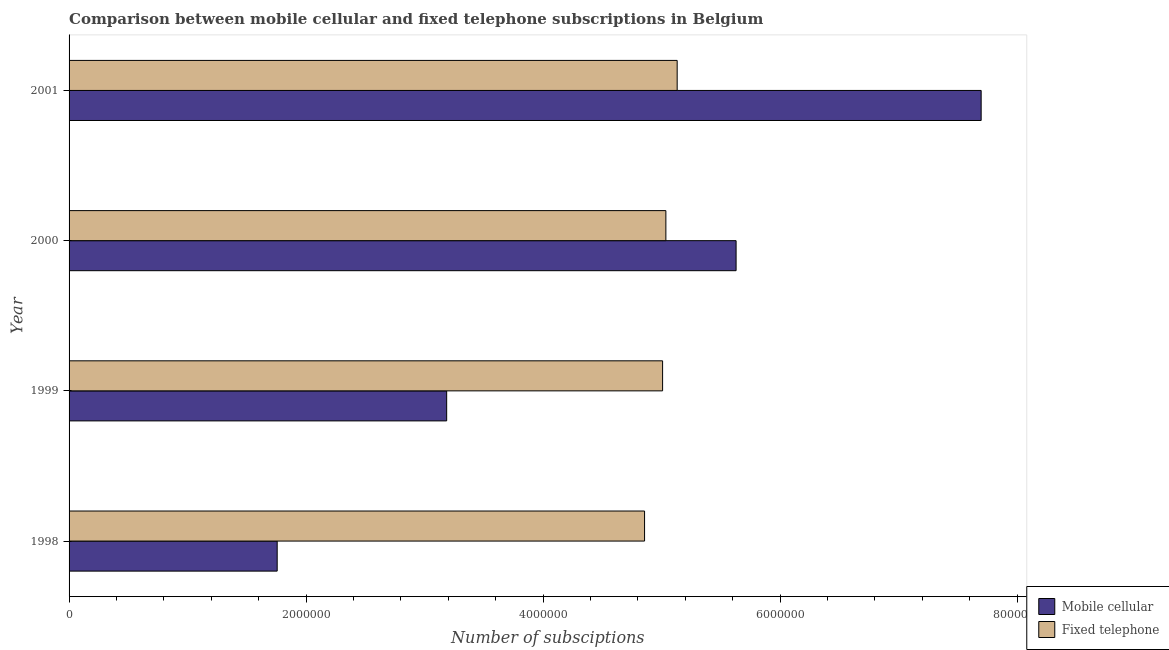How many different coloured bars are there?
Provide a succinct answer. 2. How many groups of bars are there?
Offer a very short reply. 4. Are the number of bars per tick equal to the number of legend labels?
Offer a terse response. Yes. Are the number of bars on each tick of the Y-axis equal?
Ensure brevity in your answer.  Yes. How many bars are there on the 3rd tick from the top?
Offer a terse response. 2. What is the label of the 2nd group of bars from the top?
Provide a succinct answer. 2000. In how many cases, is the number of bars for a given year not equal to the number of legend labels?
Your response must be concise. 0. What is the number of fixed telephone subscriptions in 2000?
Offer a very short reply. 5.04e+06. Across all years, what is the maximum number of mobile cellular subscriptions?
Your response must be concise. 7.70e+06. Across all years, what is the minimum number of mobile cellular subscriptions?
Your answer should be compact. 1.76e+06. In which year was the number of fixed telephone subscriptions maximum?
Provide a short and direct response. 2001. In which year was the number of mobile cellular subscriptions minimum?
Ensure brevity in your answer.  1998. What is the total number of mobile cellular subscriptions in the graph?
Your answer should be compact. 1.83e+07. What is the difference between the number of mobile cellular subscriptions in 1998 and that in 1999?
Give a very brief answer. -1.43e+06. What is the difference between the number of fixed telephone subscriptions in 1999 and the number of mobile cellular subscriptions in 2001?
Offer a very short reply. -2.69e+06. What is the average number of fixed telephone subscriptions per year?
Provide a short and direct response. 5.01e+06. In the year 2001, what is the difference between the number of mobile cellular subscriptions and number of fixed telephone subscriptions?
Give a very brief answer. 2.57e+06. In how many years, is the number of mobile cellular subscriptions greater than 2800000 ?
Ensure brevity in your answer.  3. What is the ratio of the number of fixed telephone subscriptions in 1999 to that in 2000?
Your answer should be very brief. 0.99. What is the difference between the highest and the second highest number of fixed telephone subscriptions?
Provide a succinct answer. 9.53e+04. What is the difference between the highest and the lowest number of mobile cellular subscriptions?
Offer a very short reply. 5.94e+06. What does the 1st bar from the top in 2000 represents?
Offer a terse response. Fixed telephone. What does the 2nd bar from the bottom in 1998 represents?
Give a very brief answer. Fixed telephone. Are all the bars in the graph horizontal?
Make the answer very short. Yes. How many years are there in the graph?
Offer a very short reply. 4. Does the graph contain grids?
Make the answer very short. No. Where does the legend appear in the graph?
Offer a terse response. Bottom right. What is the title of the graph?
Keep it short and to the point. Comparison between mobile cellular and fixed telephone subscriptions in Belgium. What is the label or title of the X-axis?
Provide a succinct answer. Number of subsciptions. What is the Number of subsciptions in Mobile cellular in 1998?
Your answer should be compact. 1.76e+06. What is the Number of subsciptions in Fixed telephone in 1998?
Your answer should be compact. 4.86e+06. What is the Number of subsciptions in Mobile cellular in 1999?
Make the answer very short. 3.19e+06. What is the Number of subsciptions in Fixed telephone in 1999?
Offer a very short reply. 5.01e+06. What is the Number of subsciptions in Mobile cellular in 2000?
Make the answer very short. 5.63e+06. What is the Number of subsciptions of Fixed telephone in 2000?
Give a very brief answer. 5.04e+06. What is the Number of subsciptions of Mobile cellular in 2001?
Provide a short and direct response. 7.70e+06. What is the Number of subsciptions in Fixed telephone in 2001?
Your answer should be very brief. 5.13e+06. Across all years, what is the maximum Number of subsciptions in Mobile cellular?
Ensure brevity in your answer.  7.70e+06. Across all years, what is the maximum Number of subsciptions of Fixed telephone?
Your answer should be compact. 5.13e+06. Across all years, what is the minimum Number of subsciptions in Mobile cellular?
Ensure brevity in your answer.  1.76e+06. Across all years, what is the minimum Number of subsciptions in Fixed telephone?
Ensure brevity in your answer.  4.86e+06. What is the total Number of subsciptions of Mobile cellular in the graph?
Ensure brevity in your answer.  1.83e+07. What is the total Number of subsciptions of Fixed telephone in the graph?
Keep it short and to the point. 2.00e+07. What is the difference between the Number of subsciptions of Mobile cellular in 1998 and that in 1999?
Provide a succinct answer. -1.43e+06. What is the difference between the Number of subsciptions of Fixed telephone in 1998 and that in 1999?
Make the answer very short. -1.52e+05. What is the difference between the Number of subsciptions in Mobile cellular in 1998 and that in 2000?
Provide a succinct answer. -3.87e+06. What is the difference between the Number of subsciptions in Fixed telephone in 1998 and that in 2000?
Offer a very short reply. -1.80e+05. What is the difference between the Number of subsciptions of Mobile cellular in 1998 and that in 2001?
Provide a succinct answer. -5.94e+06. What is the difference between the Number of subsciptions of Fixed telephone in 1998 and that in 2001?
Make the answer very short. -2.75e+05. What is the difference between the Number of subsciptions of Mobile cellular in 1999 and that in 2000?
Your response must be concise. -2.44e+06. What is the difference between the Number of subsciptions of Fixed telephone in 1999 and that in 2000?
Provide a short and direct response. -2.78e+04. What is the difference between the Number of subsciptions in Mobile cellular in 1999 and that in 2001?
Make the answer very short. -4.51e+06. What is the difference between the Number of subsciptions in Fixed telephone in 1999 and that in 2001?
Keep it short and to the point. -1.23e+05. What is the difference between the Number of subsciptions in Mobile cellular in 2000 and that in 2001?
Your answer should be compact. -2.07e+06. What is the difference between the Number of subsciptions of Fixed telephone in 2000 and that in 2001?
Provide a short and direct response. -9.53e+04. What is the difference between the Number of subsciptions in Mobile cellular in 1998 and the Number of subsciptions in Fixed telephone in 1999?
Provide a short and direct response. -3.25e+06. What is the difference between the Number of subsciptions of Mobile cellular in 1998 and the Number of subsciptions of Fixed telephone in 2000?
Offer a very short reply. -3.28e+06. What is the difference between the Number of subsciptions in Mobile cellular in 1998 and the Number of subsciptions in Fixed telephone in 2001?
Ensure brevity in your answer.  -3.38e+06. What is the difference between the Number of subsciptions in Mobile cellular in 1999 and the Number of subsciptions in Fixed telephone in 2000?
Keep it short and to the point. -1.85e+06. What is the difference between the Number of subsciptions of Mobile cellular in 1999 and the Number of subsciptions of Fixed telephone in 2001?
Offer a terse response. -1.95e+06. What is the difference between the Number of subsciptions in Mobile cellular in 2000 and the Number of subsciptions in Fixed telephone in 2001?
Your answer should be very brief. 4.97e+05. What is the average Number of subsciptions in Mobile cellular per year?
Provide a short and direct response. 4.57e+06. What is the average Number of subsciptions of Fixed telephone per year?
Give a very brief answer. 5.01e+06. In the year 1998, what is the difference between the Number of subsciptions in Mobile cellular and Number of subsciptions in Fixed telephone?
Your answer should be very brief. -3.10e+06. In the year 1999, what is the difference between the Number of subsciptions in Mobile cellular and Number of subsciptions in Fixed telephone?
Your response must be concise. -1.82e+06. In the year 2000, what is the difference between the Number of subsciptions of Mobile cellular and Number of subsciptions of Fixed telephone?
Your answer should be very brief. 5.93e+05. In the year 2001, what is the difference between the Number of subsciptions of Mobile cellular and Number of subsciptions of Fixed telephone?
Your answer should be very brief. 2.57e+06. What is the ratio of the Number of subsciptions of Mobile cellular in 1998 to that in 1999?
Provide a short and direct response. 0.55. What is the ratio of the Number of subsciptions in Fixed telephone in 1998 to that in 1999?
Keep it short and to the point. 0.97. What is the ratio of the Number of subsciptions in Mobile cellular in 1998 to that in 2000?
Your answer should be compact. 0.31. What is the ratio of the Number of subsciptions of Mobile cellular in 1998 to that in 2001?
Offer a very short reply. 0.23. What is the ratio of the Number of subsciptions in Fixed telephone in 1998 to that in 2001?
Keep it short and to the point. 0.95. What is the ratio of the Number of subsciptions of Mobile cellular in 1999 to that in 2000?
Your response must be concise. 0.57. What is the ratio of the Number of subsciptions of Mobile cellular in 1999 to that in 2001?
Ensure brevity in your answer.  0.41. What is the ratio of the Number of subsciptions of Mobile cellular in 2000 to that in 2001?
Provide a succinct answer. 0.73. What is the ratio of the Number of subsciptions of Fixed telephone in 2000 to that in 2001?
Provide a short and direct response. 0.98. What is the difference between the highest and the second highest Number of subsciptions of Mobile cellular?
Your answer should be compact. 2.07e+06. What is the difference between the highest and the second highest Number of subsciptions in Fixed telephone?
Ensure brevity in your answer.  9.53e+04. What is the difference between the highest and the lowest Number of subsciptions in Mobile cellular?
Give a very brief answer. 5.94e+06. What is the difference between the highest and the lowest Number of subsciptions in Fixed telephone?
Your answer should be compact. 2.75e+05. 